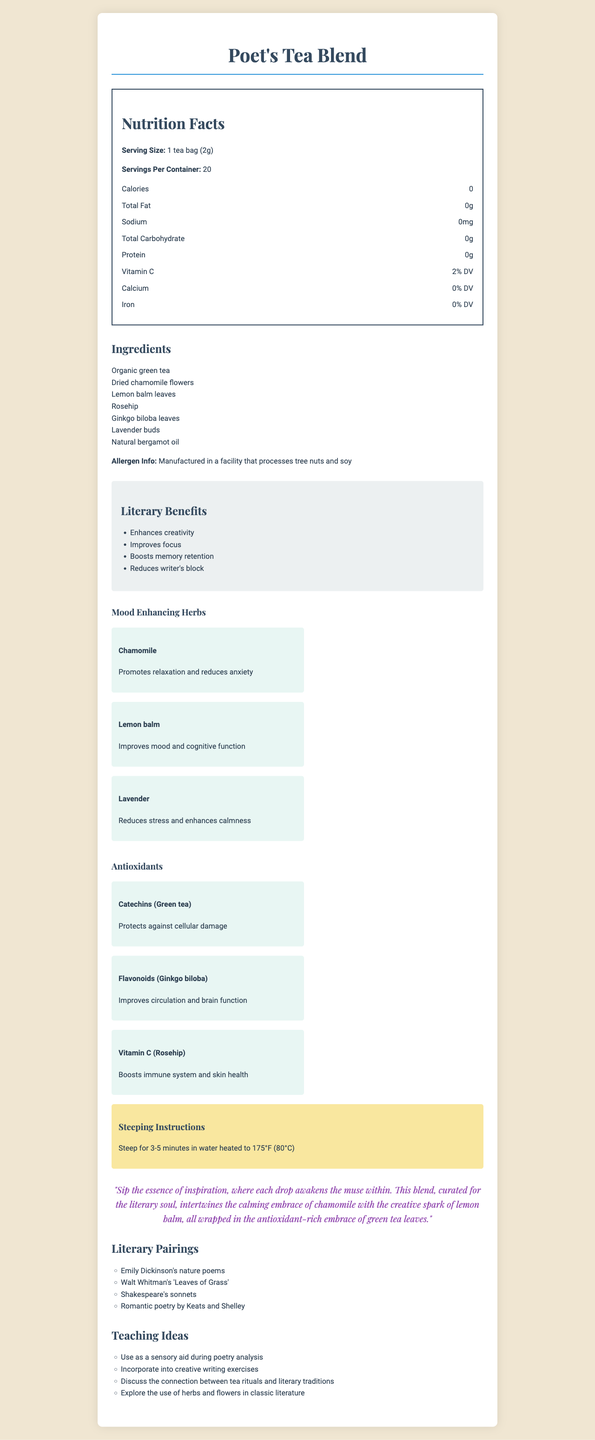what is the serving size of the Poet's Tea Blend? The serving size is explicitly stated in the Nutrition Facts section of the document as "1 tea bag (2g)".
Answer: 1 tea bag (2g) how many calories are in each serving of Poet's Tea Blend? The calories per serving are listed as 0 in the Nutrition Facts section of the document.
Answer: 0 what percentage of the daily value of Vitamin C does one serving of Poet's Tea Blend provide? The Vitamin C content is listed as 2% DV in the Nutrition Facts section.
Answer: 2% DV name two mood-enhancing herbs in Poet's Tea Blend. The mood-enhancing herbs are listed, and two of them are Chamomile and Lemon balm.
Answer: Chamomile, Lemon balm what are the steeping instructions for Poet's Tea Blend? The steeping instructions are clearly stated in the document.
Answer: Steep for 3-5 minutes in water heated to 175°F (80°C) which antioxidant in Poet's Tea Blend is derived from green tea? The antioxidants section specifies that Catechins are derived from green tea.
Answer: Catechins which literary work is recommended to pair with Poet's Tea Blend? A. Pride and Prejudice B. Leaves of Grass C. The Great Gatsby D. War and Peace The literary pairing section lists Walt Whitman's "Leaves of Grass" as a recommended literary work to pair with the tea.
Answer: B what are some of the literary benefits of Poet's Tea Blend? A. Enhances creativity B. Provides fiber C. Strengthens bones D. Cleanses the liver The literary benefits section lists "Enhances creativity" among other benefits like improving focus.
Answer: A is Poet's Tea Blend suitable for individuals with tree nut allergies? The Allergen Info states that it is manufactured in a facility that processes tree nuts, which may pose a risk for individuals with tree nut allergies.
Answer: No what are the ingredients in Poet's Tea Blend? The ingredients are listed in the ingredients section of the document.
Answer: Organic green tea, Dried chamomile flowers, Lemon balm leaves, Rosehip, Ginkgo biloba leaves, Lavender buds, Natural bergamot oil what is the poetic description of Poet's Tea Blend? The poetic description is mentioned verbatim in the document.
Answer: "Sip the essence of inspiration, where each drop awakens the muse within. This blend, curated for the literary soul, intertwines the calming embrace of chamomile with the creative spark of lemon balm, all wrapped in the antioxidant-rich embrace of green tea leaves." explain how Poet's Tea Blend can be used in a classroom setting. The teaching ideas section provides these uses explicitly.
Answer: Poet's Tea Blend can be used as a sensory aid during poetry analysis, incorporated into creative writing exercises, discussed for the connection between tea rituals and literary traditions, and explored for the use of herbs and flowers in classic literature. can you identify the exact percentage of iron provided by Poet's Tea Blend per serving? The Nutrition Facts section lists the iron content as 0% DV.
Answer: 0% DV summarize the main ideas presented in the Poet's Tea Blend document. The document comprehensively outlines all aspects of the tea blend, emphasizing its use and benefits for literary purposes and classroom activities.
Answer: The document provides detailed information about the Poet's Tea Blend, including its nutritional facts, ingredients, allergen information, and benefits. It emphasizes the tea's literary benefits such as enhancing creativity and improving focus, mood-enhancing herbs, antioxidants, and specific literary pairings. Instructions on how to steep the tea, a poetic description, and ideas for using the tea in a classroom setting are also included. how much sodium is in each serving of Poet's Tea Blend? The Nutrition Facts section lists the sodium content as 0mg.
Answer: 0mg can you determine the price of Poet's Tea Blend from the document? The document does not provide any information regarding the price of the tea blend.
Answer: Not enough information 